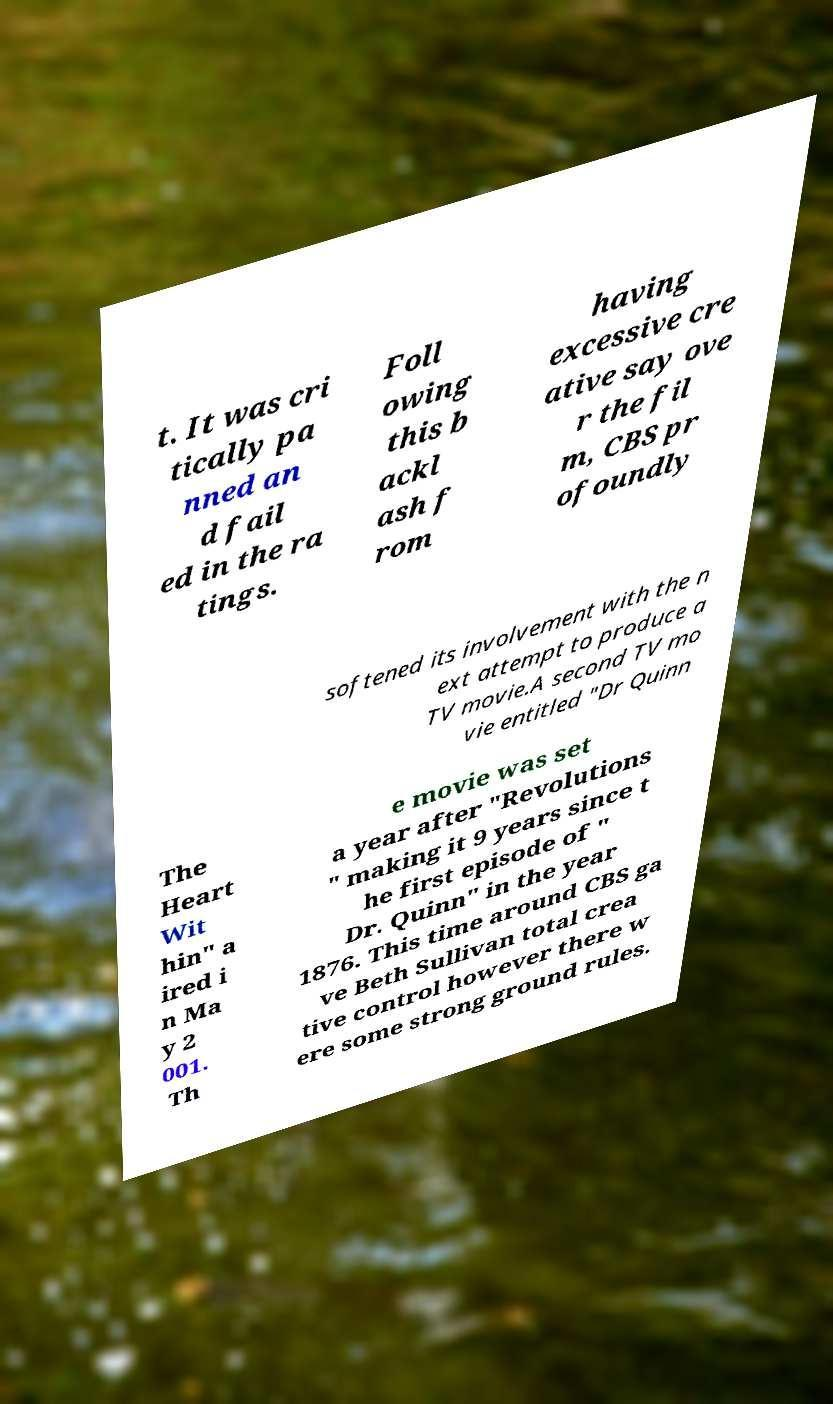There's text embedded in this image that I need extracted. Can you transcribe it verbatim? t. It was cri tically pa nned an d fail ed in the ra tings. Foll owing this b ackl ash f rom having excessive cre ative say ove r the fil m, CBS pr ofoundly softened its involvement with the n ext attempt to produce a TV movie.A second TV mo vie entitled "Dr Quinn The Heart Wit hin" a ired i n Ma y 2 001. Th e movie was set a year after "Revolutions " making it 9 years since t he first episode of " Dr. Quinn" in the year 1876. This time around CBS ga ve Beth Sullivan total crea tive control however there w ere some strong ground rules. 